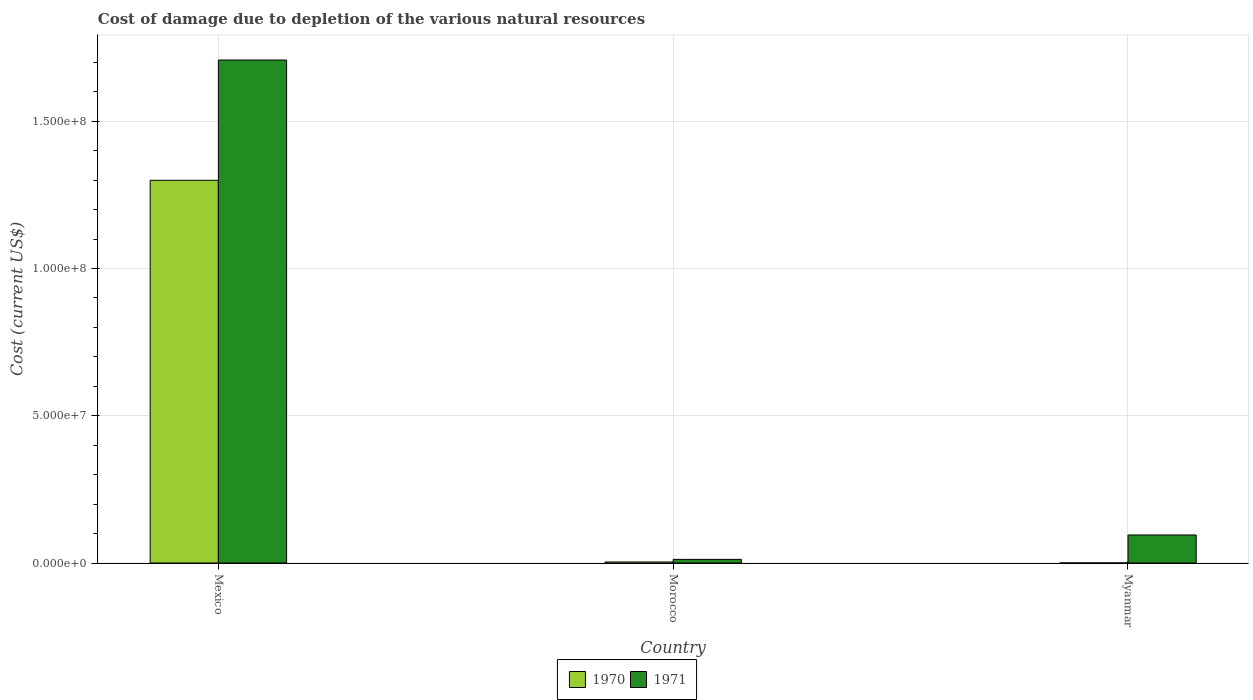Are the number of bars per tick equal to the number of legend labels?
Keep it short and to the point. Yes. How many bars are there on the 2nd tick from the right?
Keep it short and to the point. 2. What is the label of the 1st group of bars from the left?
Keep it short and to the point. Mexico. What is the cost of damage caused due to the depletion of various natural resources in 1971 in Morocco?
Make the answer very short. 1.24e+06. Across all countries, what is the maximum cost of damage caused due to the depletion of various natural resources in 1970?
Your response must be concise. 1.30e+08. Across all countries, what is the minimum cost of damage caused due to the depletion of various natural resources in 1971?
Provide a short and direct response. 1.24e+06. In which country was the cost of damage caused due to the depletion of various natural resources in 1970 maximum?
Ensure brevity in your answer.  Mexico. In which country was the cost of damage caused due to the depletion of various natural resources in 1971 minimum?
Give a very brief answer. Morocco. What is the total cost of damage caused due to the depletion of various natural resources in 1970 in the graph?
Your answer should be compact. 1.30e+08. What is the difference between the cost of damage caused due to the depletion of various natural resources in 1970 in Morocco and that in Myanmar?
Make the answer very short. 3.12e+05. What is the difference between the cost of damage caused due to the depletion of various natural resources in 1971 in Morocco and the cost of damage caused due to the depletion of various natural resources in 1970 in Myanmar?
Offer a terse response. 1.20e+06. What is the average cost of damage caused due to the depletion of various natural resources in 1971 per country?
Make the answer very short. 6.05e+07. What is the difference between the cost of damage caused due to the depletion of various natural resources of/in 1971 and cost of damage caused due to the depletion of various natural resources of/in 1970 in Myanmar?
Ensure brevity in your answer.  9.49e+06. What is the ratio of the cost of damage caused due to the depletion of various natural resources in 1971 in Mexico to that in Morocco?
Offer a very short reply. 137.31. Is the cost of damage caused due to the depletion of various natural resources in 1971 in Morocco less than that in Myanmar?
Keep it short and to the point. Yes. Is the difference between the cost of damage caused due to the depletion of various natural resources in 1971 in Mexico and Myanmar greater than the difference between the cost of damage caused due to the depletion of various natural resources in 1970 in Mexico and Myanmar?
Offer a very short reply. Yes. What is the difference between the highest and the second highest cost of damage caused due to the depletion of various natural resources in 1971?
Your response must be concise. 1.70e+08. What is the difference between the highest and the lowest cost of damage caused due to the depletion of various natural resources in 1971?
Your answer should be compact. 1.70e+08. In how many countries, is the cost of damage caused due to the depletion of various natural resources in 1970 greater than the average cost of damage caused due to the depletion of various natural resources in 1970 taken over all countries?
Ensure brevity in your answer.  1. What does the 2nd bar from the left in Mexico represents?
Give a very brief answer. 1971. Are the values on the major ticks of Y-axis written in scientific E-notation?
Keep it short and to the point. Yes. What is the title of the graph?
Ensure brevity in your answer.  Cost of damage due to depletion of the various natural resources. Does "1976" appear as one of the legend labels in the graph?
Your answer should be compact. No. What is the label or title of the X-axis?
Offer a very short reply. Country. What is the label or title of the Y-axis?
Your answer should be compact. Cost (current US$). What is the Cost (current US$) in 1970 in Mexico?
Provide a short and direct response. 1.30e+08. What is the Cost (current US$) in 1971 in Mexico?
Provide a succinct answer. 1.71e+08. What is the Cost (current US$) of 1970 in Morocco?
Ensure brevity in your answer.  3.51e+05. What is the Cost (current US$) in 1971 in Morocco?
Your answer should be compact. 1.24e+06. What is the Cost (current US$) of 1970 in Myanmar?
Provide a succinct answer. 3.91e+04. What is the Cost (current US$) in 1971 in Myanmar?
Offer a terse response. 9.53e+06. Across all countries, what is the maximum Cost (current US$) of 1970?
Provide a short and direct response. 1.30e+08. Across all countries, what is the maximum Cost (current US$) of 1971?
Your response must be concise. 1.71e+08. Across all countries, what is the minimum Cost (current US$) in 1970?
Ensure brevity in your answer.  3.91e+04. Across all countries, what is the minimum Cost (current US$) of 1971?
Make the answer very short. 1.24e+06. What is the total Cost (current US$) in 1970 in the graph?
Provide a short and direct response. 1.30e+08. What is the total Cost (current US$) of 1971 in the graph?
Keep it short and to the point. 1.82e+08. What is the difference between the Cost (current US$) in 1970 in Mexico and that in Morocco?
Your answer should be very brief. 1.30e+08. What is the difference between the Cost (current US$) in 1971 in Mexico and that in Morocco?
Offer a terse response. 1.70e+08. What is the difference between the Cost (current US$) of 1970 in Mexico and that in Myanmar?
Ensure brevity in your answer.  1.30e+08. What is the difference between the Cost (current US$) of 1971 in Mexico and that in Myanmar?
Offer a very short reply. 1.61e+08. What is the difference between the Cost (current US$) in 1970 in Morocco and that in Myanmar?
Offer a very short reply. 3.12e+05. What is the difference between the Cost (current US$) of 1971 in Morocco and that in Myanmar?
Ensure brevity in your answer.  -8.28e+06. What is the difference between the Cost (current US$) in 1970 in Mexico and the Cost (current US$) in 1971 in Morocco?
Your answer should be compact. 1.29e+08. What is the difference between the Cost (current US$) of 1970 in Mexico and the Cost (current US$) of 1971 in Myanmar?
Your answer should be compact. 1.20e+08. What is the difference between the Cost (current US$) in 1970 in Morocco and the Cost (current US$) in 1971 in Myanmar?
Make the answer very short. -9.17e+06. What is the average Cost (current US$) in 1970 per country?
Your answer should be very brief. 4.35e+07. What is the average Cost (current US$) of 1971 per country?
Ensure brevity in your answer.  6.05e+07. What is the difference between the Cost (current US$) in 1970 and Cost (current US$) in 1971 in Mexico?
Ensure brevity in your answer.  -4.08e+07. What is the difference between the Cost (current US$) of 1970 and Cost (current US$) of 1971 in Morocco?
Offer a terse response. -8.93e+05. What is the difference between the Cost (current US$) in 1970 and Cost (current US$) in 1971 in Myanmar?
Provide a succinct answer. -9.49e+06. What is the ratio of the Cost (current US$) in 1970 in Mexico to that in Morocco?
Make the answer very short. 369.8. What is the ratio of the Cost (current US$) of 1971 in Mexico to that in Morocco?
Provide a succinct answer. 137.31. What is the ratio of the Cost (current US$) of 1970 in Mexico to that in Myanmar?
Keep it short and to the point. 3325.6. What is the ratio of the Cost (current US$) of 1971 in Mexico to that in Myanmar?
Ensure brevity in your answer.  17.93. What is the ratio of the Cost (current US$) of 1970 in Morocco to that in Myanmar?
Ensure brevity in your answer.  8.99. What is the ratio of the Cost (current US$) in 1971 in Morocco to that in Myanmar?
Your answer should be compact. 0.13. What is the difference between the highest and the second highest Cost (current US$) in 1970?
Provide a succinct answer. 1.30e+08. What is the difference between the highest and the second highest Cost (current US$) of 1971?
Offer a very short reply. 1.61e+08. What is the difference between the highest and the lowest Cost (current US$) in 1970?
Ensure brevity in your answer.  1.30e+08. What is the difference between the highest and the lowest Cost (current US$) in 1971?
Make the answer very short. 1.70e+08. 